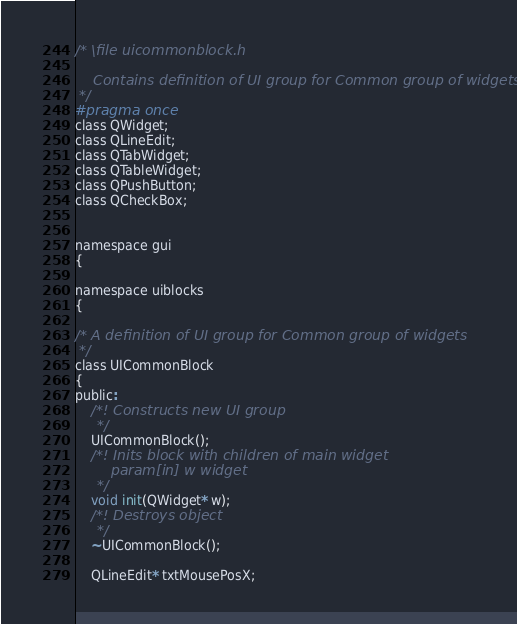Convert code to text. <code><loc_0><loc_0><loc_500><loc_500><_C_>/* \file uicommonblock.h

    Contains definition of UI group for Common group of widgets
 */
#pragma once
class QWidget;
class QLineEdit;
class QTabWidget;
class QTableWidget;
class QPushButton;
class QCheckBox;


namespace gui
{

namespace uiblocks
{

/* A definition of UI group for Common group of widgets
 */
class UICommonBlock
{
public:
    /*! Constructs new UI group
     */
    UICommonBlock();
    /*! Inits block with children of main widget
        param[in] w widget
     */
    void init(QWidget* w);
    /*! Destroys object
     */
    ~UICommonBlock();

    QLineEdit* txtMousePosX;</code> 